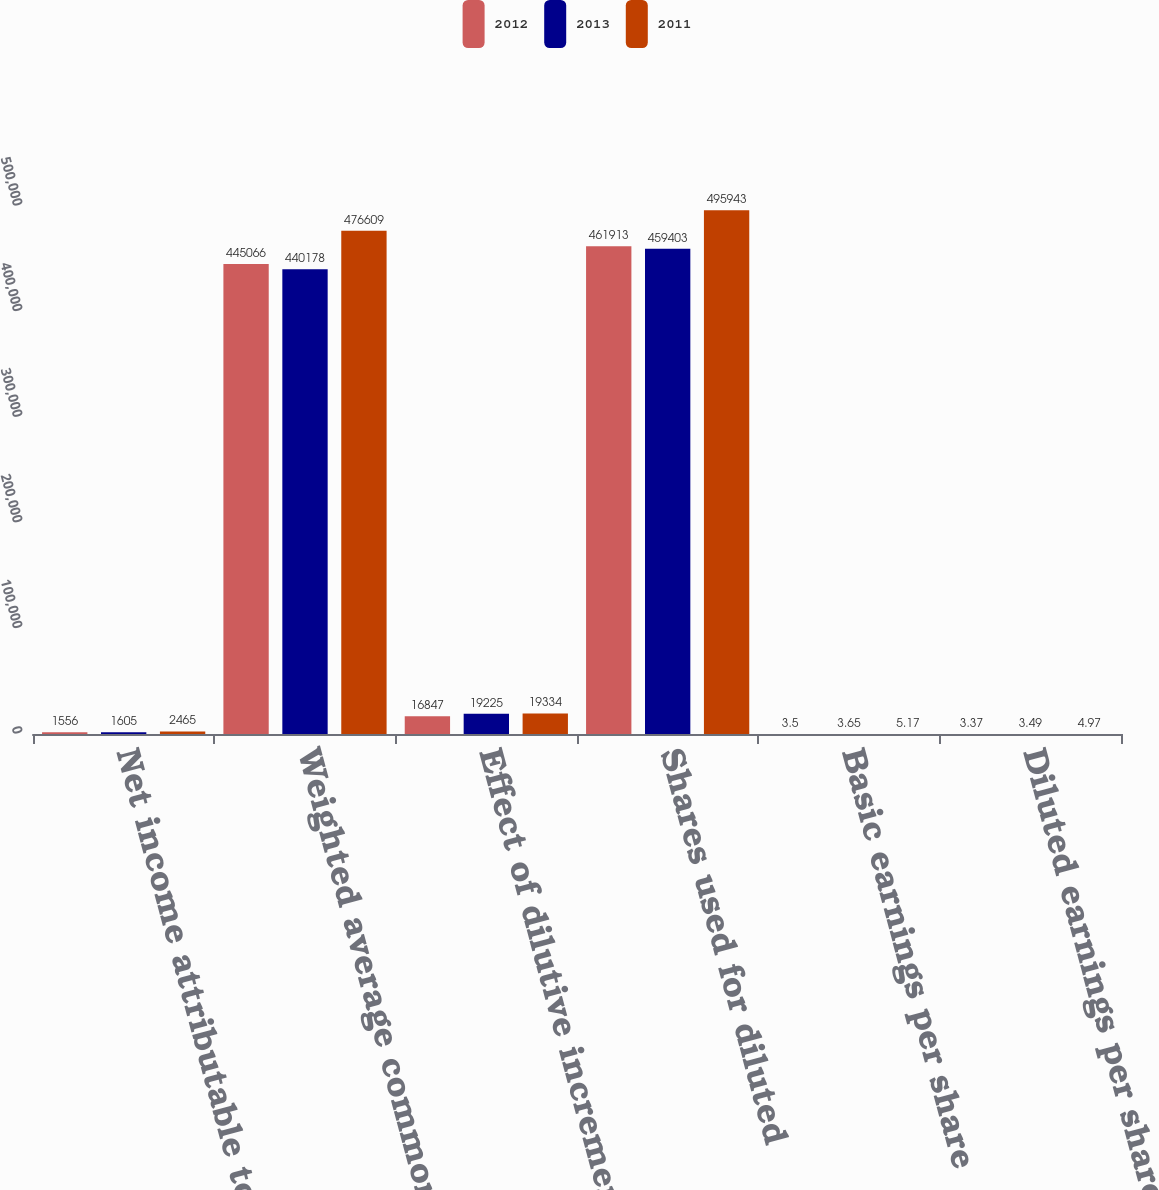Convert chart. <chart><loc_0><loc_0><loc_500><loc_500><stacked_bar_chart><ecel><fcel>Net income attributable to HCA<fcel>Weighted average common shares<fcel>Effect of dilutive incremental<fcel>Shares used for diluted<fcel>Basic earnings per share<fcel>Diluted earnings per share<nl><fcel>2012<fcel>1556<fcel>445066<fcel>16847<fcel>461913<fcel>3.5<fcel>3.37<nl><fcel>2013<fcel>1605<fcel>440178<fcel>19225<fcel>459403<fcel>3.65<fcel>3.49<nl><fcel>2011<fcel>2465<fcel>476609<fcel>19334<fcel>495943<fcel>5.17<fcel>4.97<nl></chart> 